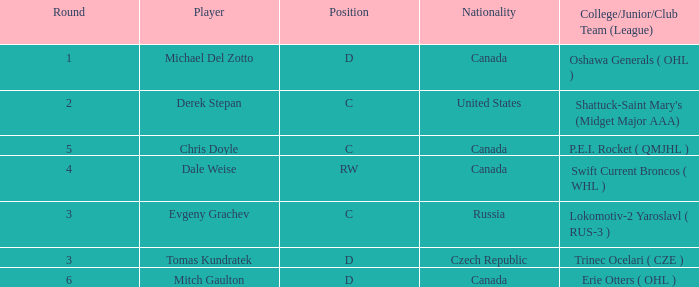What is Michael Del Zotto's nationality? Canada. 